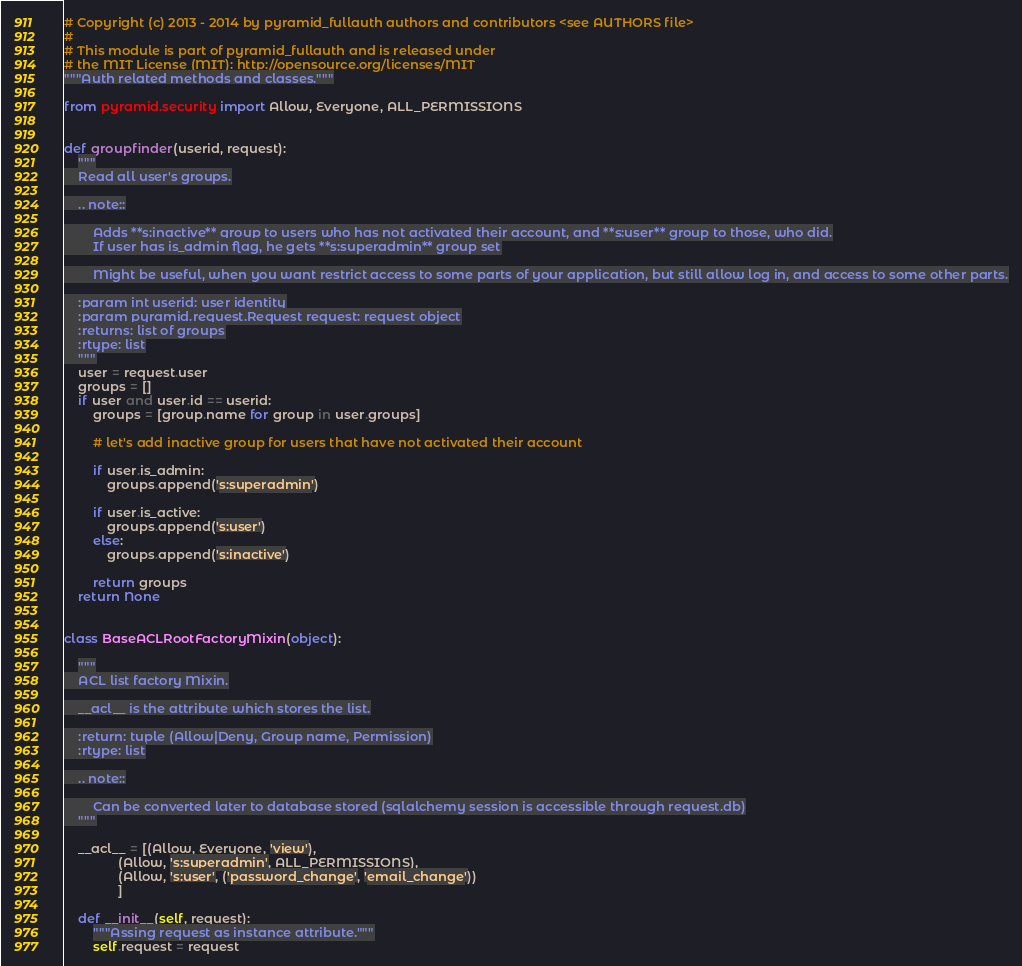<code> <loc_0><loc_0><loc_500><loc_500><_Python_># Copyright (c) 2013 - 2014 by pyramid_fullauth authors and contributors <see AUTHORS file>
#
# This module is part of pyramid_fullauth and is released under
# the MIT License (MIT): http://opensource.org/licenses/MIT
"""Auth related methods and classes."""

from pyramid.security import Allow, Everyone, ALL_PERMISSIONS


def groupfinder(userid, request):
    """
    Read all user's groups.

    .. note::

        Adds **s:inactive** group to users who has not activated their account, and **s:user** group to those, who did.
        If user has is_admin flag, he gets **s:superadmin** group set

        Might be useful, when you want restrict access to some parts of your application, but still allow log in, and access to some other parts.

    :param int userid: user identity
    :param pyramid.request.Request request: request object
    :returns: list of groups
    :rtype: list
    """
    user = request.user
    groups = []
    if user and user.id == userid:
        groups = [group.name for group in user.groups]

        # let's add inactive group for users that have not activated their account

        if user.is_admin:
            groups.append('s:superadmin')

        if user.is_active:
            groups.append('s:user')
        else:
            groups.append('s:inactive')

        return groups
    return None


class BaseACLRootFactoryMixin(object):

    """
    ACL list factory Mixin.

    __acl__ is the attribute which stores the list.

    :return: tuple (Allow|Deny, Group name, Permission)
    :rtype: list

    .. note::

        Can be converted later to database stored (sqlalchemy session is accessible through request.db)
    """

    __acl__ = [(Allow, Everyone, 'view'),
               (Allow, 's:superadmin', ALL_PERMISSIONS),
               (Allow, 's:user', ('password_change', 'email_change'))
               ]

    def __init__(self, request):
        """Assing request as instance attribute."""
        self.request = request
</code> 